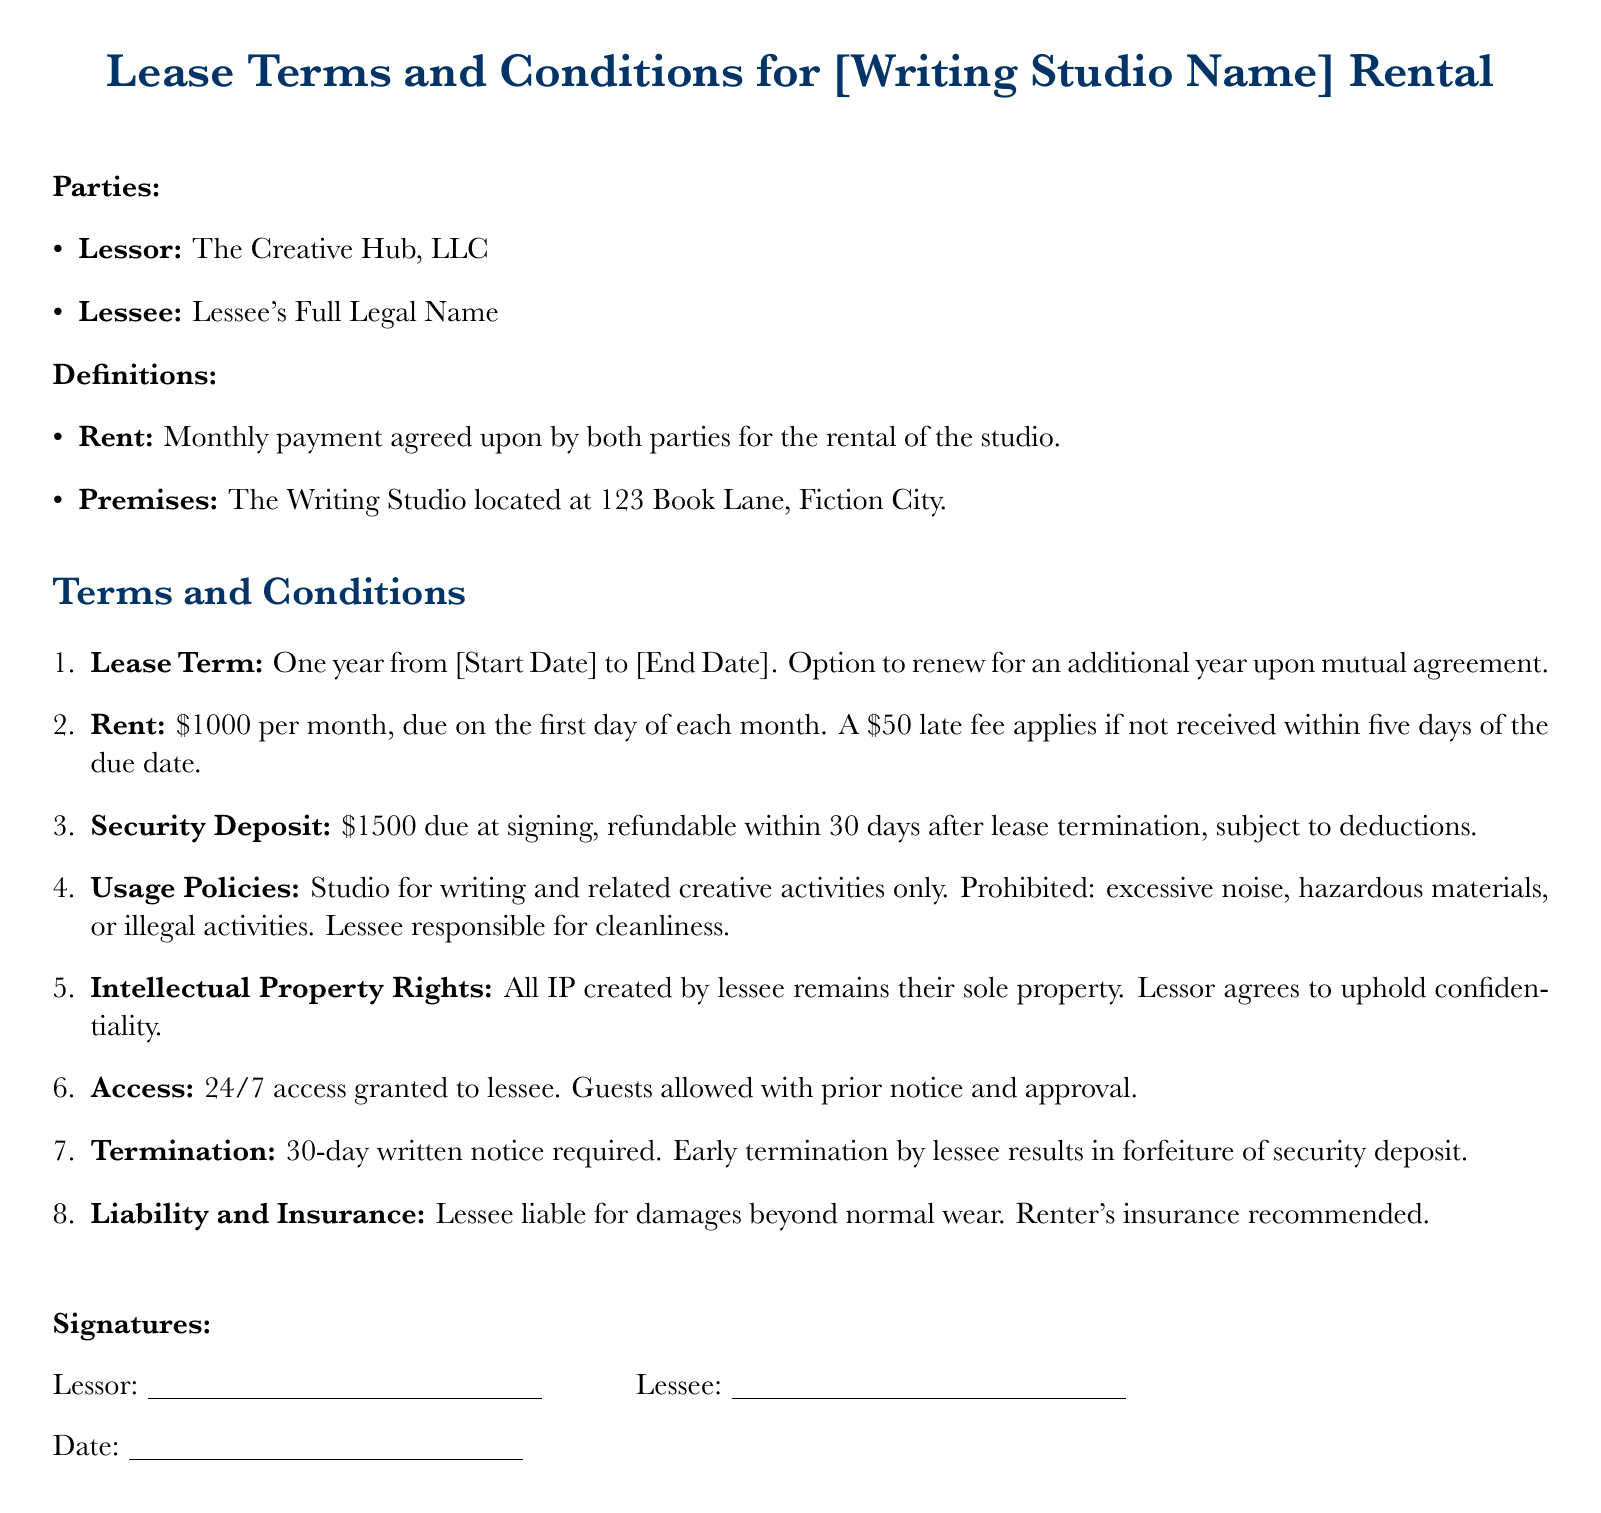What is the name of the lessor? The name of the lessor is specified in the parties section of the document.
Answer: The Creative Hub, LLC What is the duration of the lease term? The lease term is stated clearly in the terms and conditions section of the document.
Answer: One year What is the monthly rent for the studio? The rent amount is detailed in the terms and conditions section.
Answer: $1000 What is the late fee amount? The late fee is mentioned in the rent subsection of the terms and conditions.
Answer: $50 What is required for early termination by the lessee? The condition for early termination is outlined in the termination clause.
Answer: 30-day written notice Who retains the intellectual property rights? The document specifies in the intellectual property rights clause who retains the rights.
Answer: Lessee What is the security deposit amount? The security deposit is listed in the terms and conditions section.
Answer: $1500 What type of activities are prohibited in the studio? The prohibited activities are stated in the usage policies section of the document.
Answer: Hazardous materials, illegal activities How soon will the security deposit be refunded? The timeline for the security deposit refund is mentioned in the security deposit section.
Answer: 30 days after lease termination 